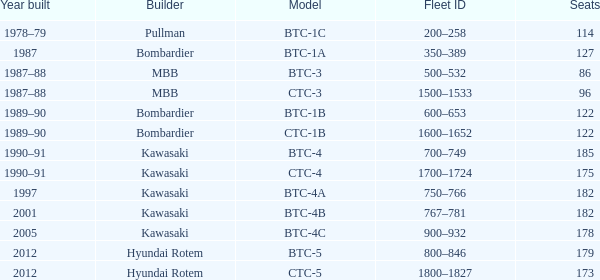How many seats does the BTC-5 model have? 179.0. 